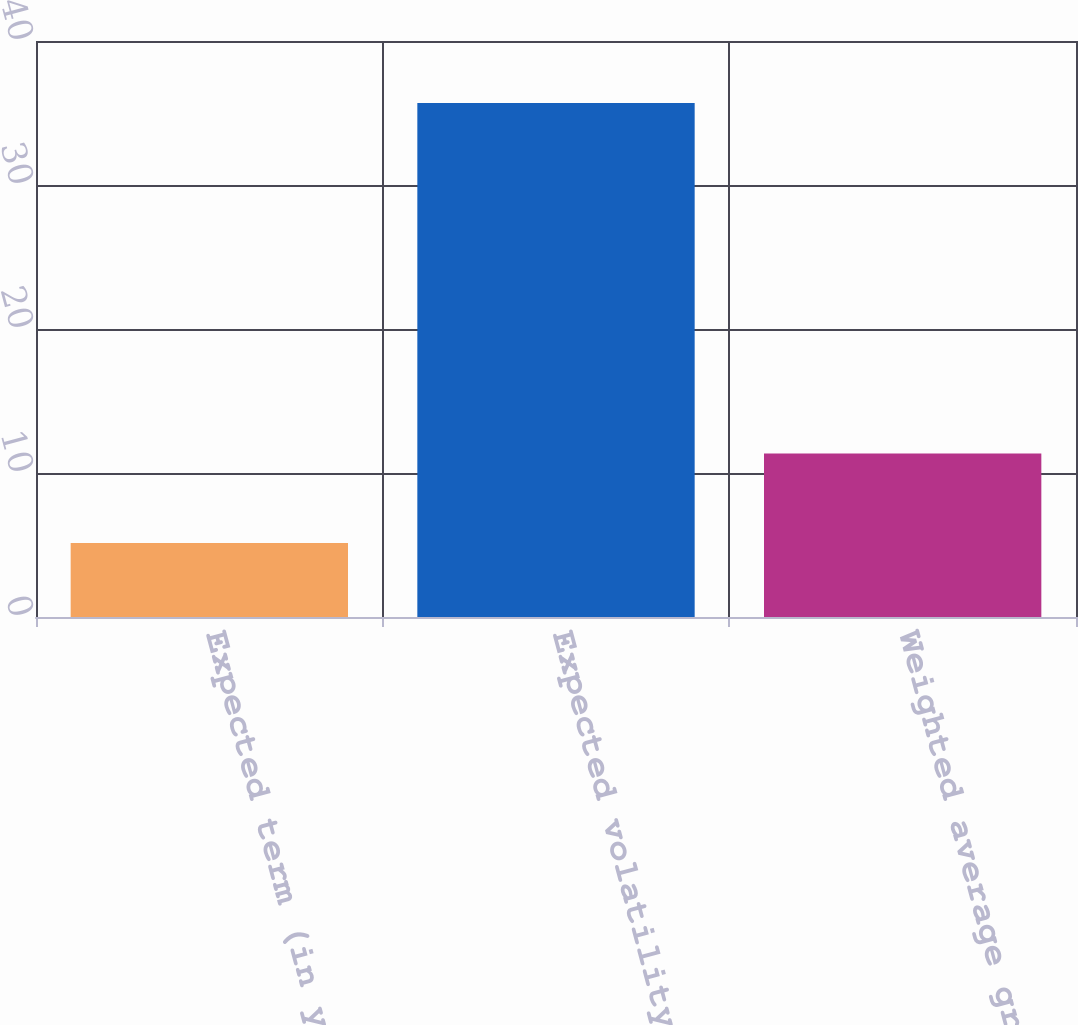Convert chart to OTSL. <chart><loc_0><loc_0><loc_500><loc_500><bar_chart><fcel>Expected term (in years)<fcel>Expected volatility<fcel>Weighted average grant-date<nl><fcel>5.14<fcel>35.7<fcel>11.35<nl></chart> 